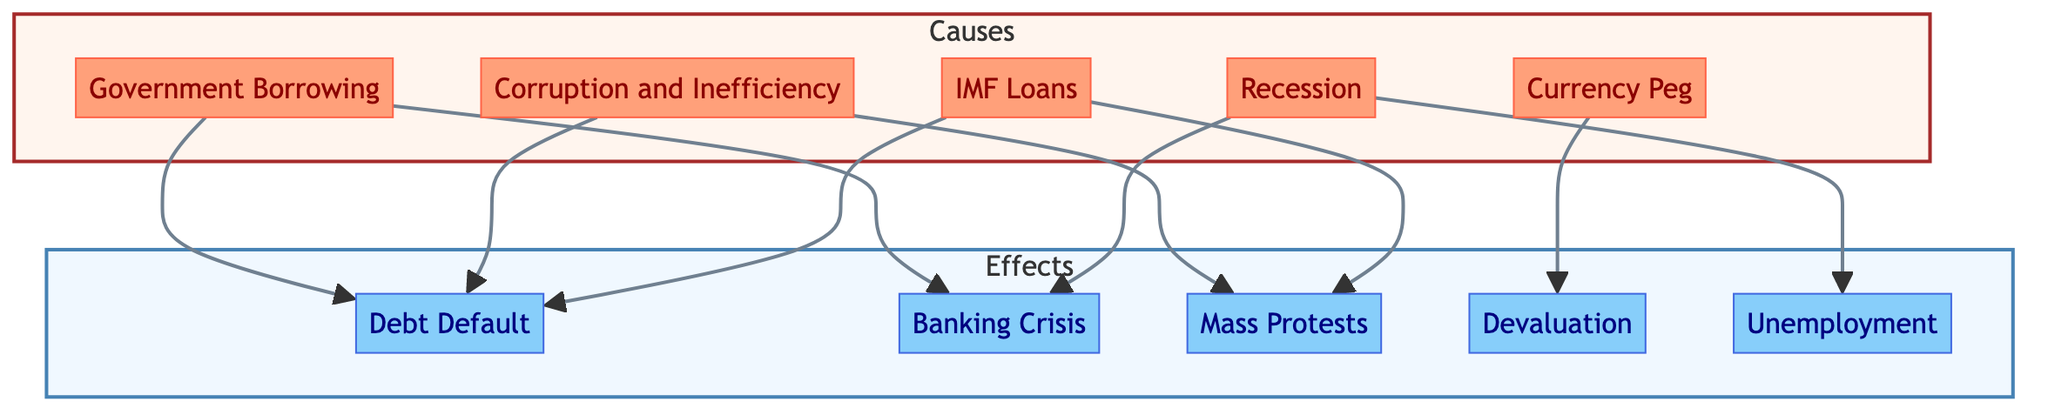What are the causes of the Argentine Financial Crisis? The diagram lists several causes: Government Borrowing, Currency Peg, Corruption and Inefficiency, Recession, and IMF Loans.
Answer: Government Borrowing, Currency Peg, Corruption and Inefficiency, Recession, IMF Loans What is the effect of Government Borrowing? According to the diagram, the effect of Government Borrowing leads to both Debt Default and Banking Crisis.
Answer: Debt Default, Banking Crisis How many nodes represent effects in the flowchart? By counting the nodes labeled under the Effects subgraph, we find there are five effects: Debt Default, Banking Crisis, Mass Protests, Devaluation, and Unemployment.
Answer: Five Which cause is directly connected to the Mass Protests effect? The Mass Protests effect is directly connected to Corruption and Inefficiency and IMF Loans as per the diagram.
Answer: Corruption and Inefficiency, IMF Loans What is the relationship between Currency Peg and Devaluation? The Currency Peg causes Devaluation according to the directional flow from Currency Peg to Devaluation in the diagram.
Answer: Currency Peg causes Devaluation Which cause has the most connections to effects in the diagram? Upon examining the connections, both Government Borrowing and Corruption and Inefficiency have three connections leading to effects, thus they have the most connections.
Answer: Government Borrowing, Corruption and Inefficiency What is a prominent effect of the Recession? The Recession leads to both Unemployment and Banking Crisis as shown in the flowchart, indicating its significant impact on these outcomes.
Answer: Unemployment, Banking Crisis What consequence does IMF Loans imply in this flowchart? The box for IMF Loans in the diagram indicates that it contributes to Debt Default and Mass Protests, reflecting its implications in the crisis.
Answer: Debt Default, Mass Protests 